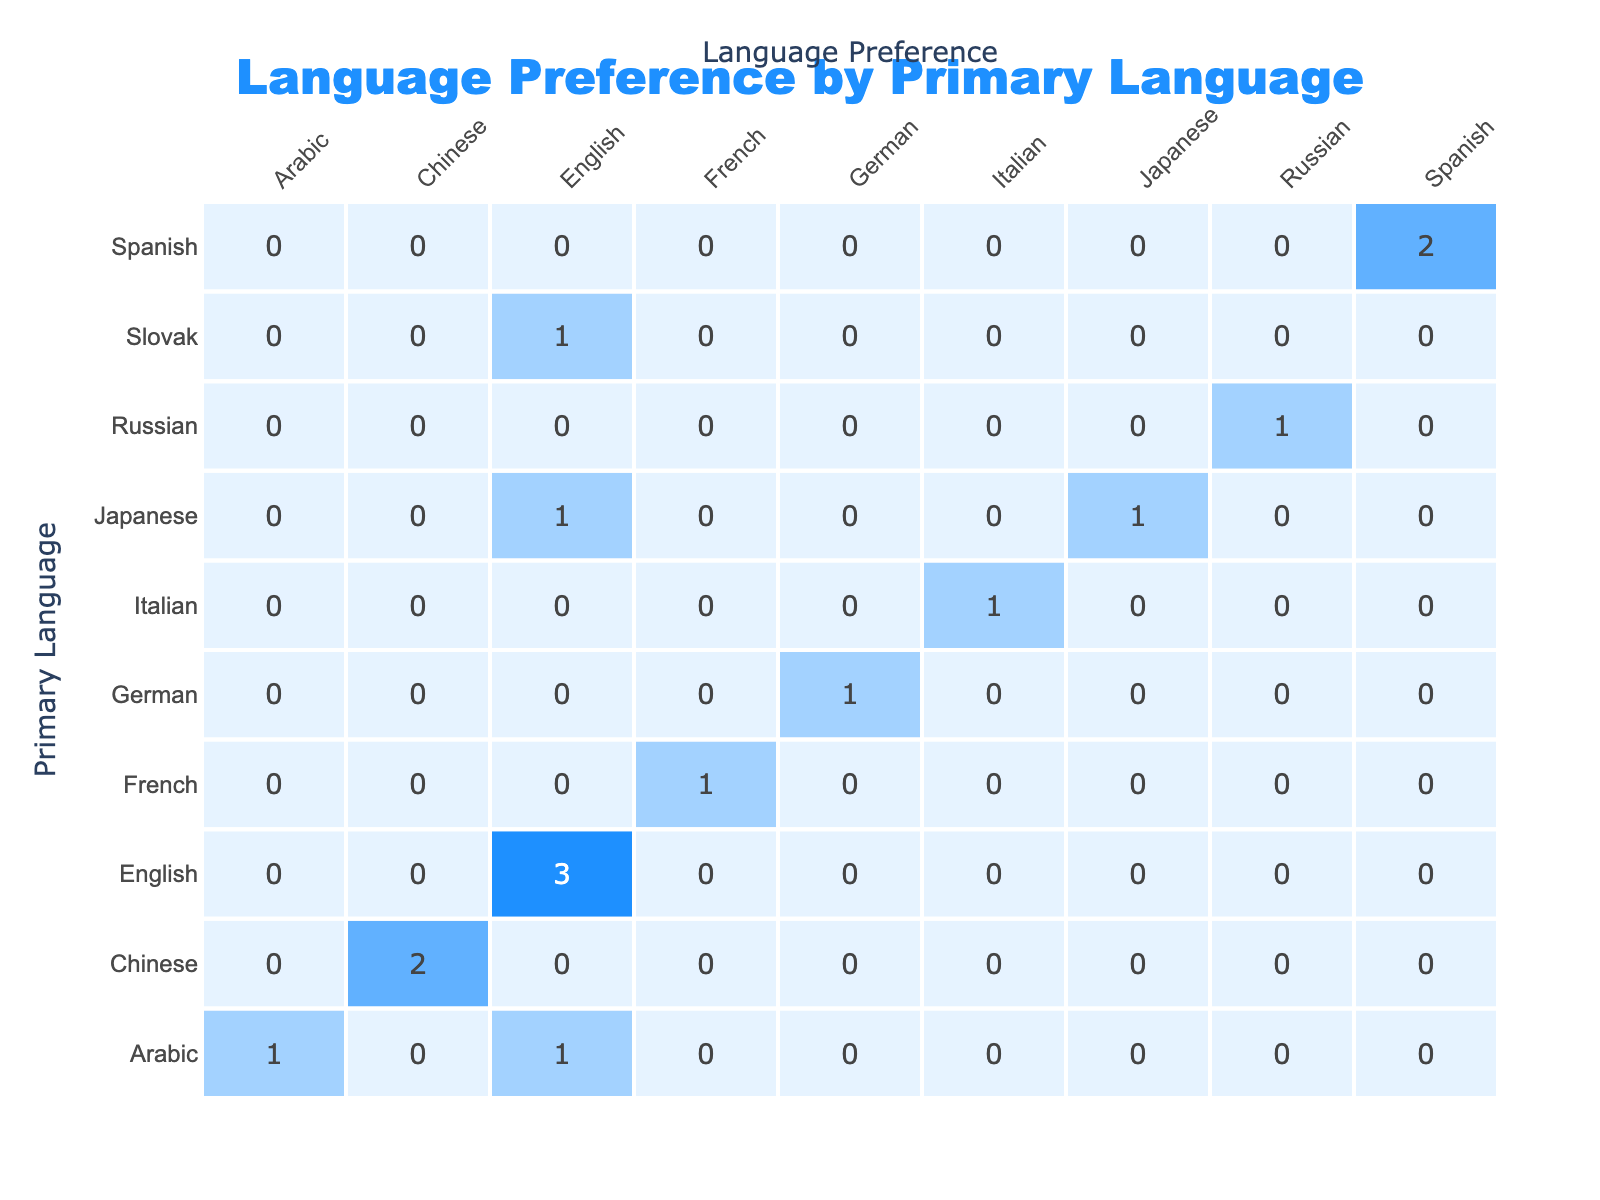What is the primary language of the team member who prefers English? Alice, John, Michael, and Fatima all prefer English. Their primary languages are English (Alice, John, Michael) and Arabic (Fatima).
Answer: English, Arabic How many team members prefer Spanish as their language preference? Alice, Carlos, and Pedro prefer Spanish. Counting them gives us a total of three members.
Answer: 3 Is there anyone whose primary language is Chinese and prefers Chinese? Chen has Chinese as his primary language and also prefers Chinese. Therefore, the statement is true.
Answer: Yes Which primary language has the highest frequency of language preference consistency? English has the highest frequency, with Alice, John, and Michael all preferring English with that being their primary language as well.
Answer: English What is the average number of members per language preference? The total number of team members is 15. The preferences are divided among five categories: English, Spanish, French, Japanese, and Arabic. Summing up the counts yields 15 (the total team size). Thus, the average is 15/5 = 3.
Answer: 3 Who are the team members whose primary language is Arabic, and what is their language preference? Fatima has Arabic as her primary language and prefers English, while Aisha also speaks Arabic and prefers Arabic. The two members are Fatima (English) and Aisha (Arabic).
Answer: Fatima (English), Aisha (Arabic) How many team members have the same primary and secondary language? Only one team member, Liu, has Chinese as both primary and secondary languages, so the answer is one.
Answer: 1 Which language preference is most frequently associated with Japanese as a primary language? Akira has Japanese as his primary language and prefers English, making it English the most frequent language preference associated with Japanese.
Answer: English 